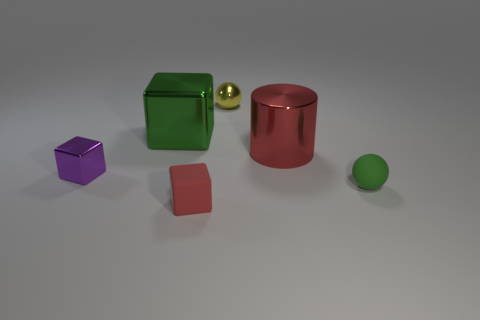How many yellow things are there?
Provide a succinct answer. 1. There is a red thing behind the red block; how big is it?
Keep it short and to the point. Large. Do the purple object and the green ball have the same size?
Give a very brief answer. Yes. What number of objects are either small purple metal things or purple things to the left of the small green thing?
Offer a very short reply. 1. What is the material of the tiny green object?
Offer a very short reply. Rubber. Is there any other thing of the same color as the small shiny ball?
Keep it short and to the point. No. Is the shape of the green metallic thing the same as the large red metallic thing?
Provide a short and direct response. No. There is a red object that is behind the tiny metal thing left of the ball behind the tiny green sphere; how big is it?
Provide a succinct answer. Large. How many other objects are the same material as the big green block?
Give a very brief answer. 3. What color is the tiny object behind the green metal thing?
Your response must be concise. Yellow. 